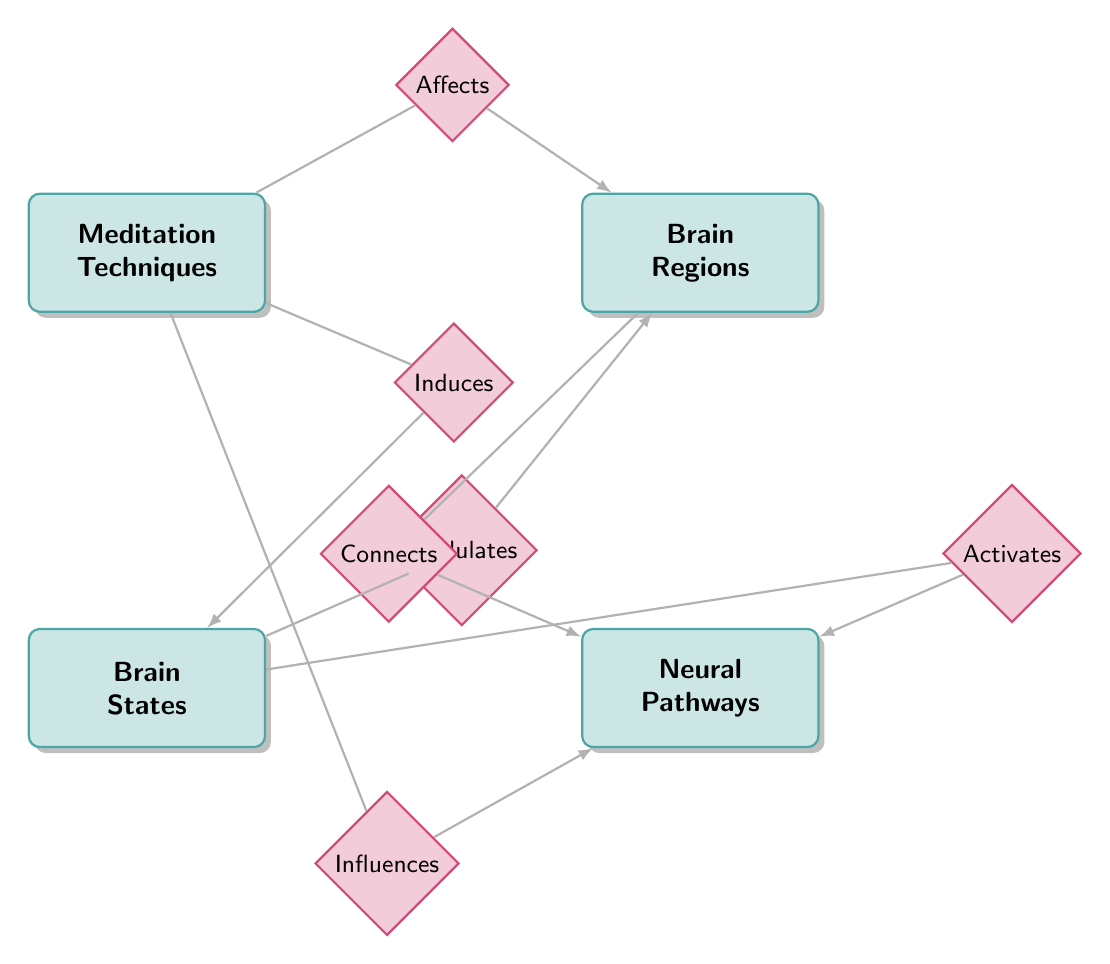What are the meditation techniques listed in the diagram? The diagram specifies four meditation techniques which are Mindfulness, Loving-Kindness, Body Scan, and Transcendental.
Answer: Mindfulness, Loving-Kindness, Body Scan, Transcendental Which brain region is influenced by meditation techniques? The diagram indicates that meditation techniques affect several brain regions, specifically mentioning the Prefrontal Cortex, Amygdala, Hippocampus, and Default Mode Network.
Answer: Prefrontal Cortex, Amygdala, Hippocampus, Default Mode Network How many brain states are represented in the diagram? There are three brain states listed in the diagram, which are Focused Attention, Relaxed Awareness, and Open Monitoring.
Answer: 3 What relationship connects brain states to neural pathways? The diagram shows the relationship 'Activates’ between brain states and neural pathways, indicating that different brain states can activate various neural pathways.
Answer: Activates Which neural pathway connects to brain regions? The diagram has a relationship called 'Connects' between brain regions and neural pathways, indicating that certain brain regions are connected to specific neural pathways in the brain.
Answer: Connects Which meditation technique induces brain states? The relationship labeled as 'Induces' between meditation techniques and brain states shows that meditation techniques directly result in certain brain states being experienced.
Answer: Induces What is the relationship type between brain states and brain regions? The diagram outlines the 'Modulates' relationship, showing that brain states can modulate brain regions, affecting how they operate during different states of consciousness.
Answer: Modulates Which brain region is directly affected by meditation techniques? Among the specified brain regions, the Prefrontal Cortex is one that can be affected directly by various meditation techniques as indicated in the relationship ‘Affects’.
Answer: Prefrontal Cortex How many nodes are there in the diagram? The diagram consists of four main nodes, namely Meditation Techniques, Brain Regions, Brain States, and Neural Pathways.
Answer: 4 